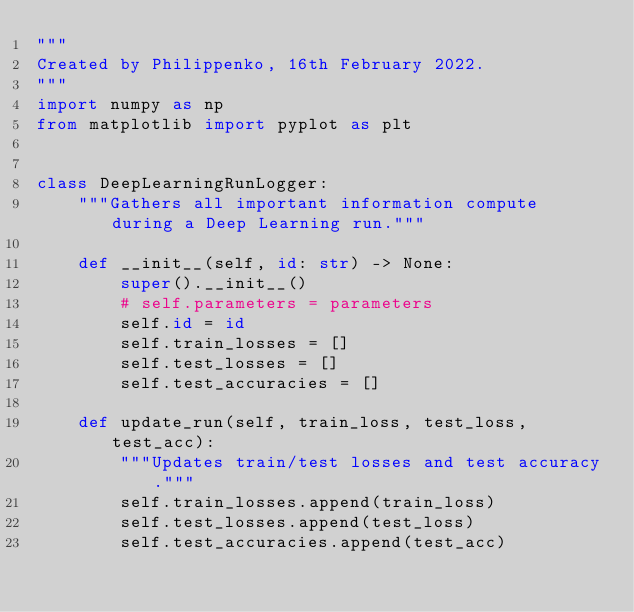Convert code to text. <code><loc_0><loc_0><loc_500><loc_500><_Python_>"""
Created by Philippenko, 16th February 2022.
"""
import numpy as np
from matplotlib import pyplot as plt


class DeepLearningRunLogger:
    """Gathers all important information compute during a Deep Learning run."""

    def __init__(self, id: str) -> None:
        super().__init__()
        # self.parameters = parameters
        self.id = id
        self.train_losses = []
        self.test_losses = []
        self.test_accuracies = []

    def update_run(self, train_loss, test_loss, test_acc):
        """Updates train/test losses and test accuracy."""
        self.train_losses.append(train_loss)
        self.test_losses.append(test_loss)
        self.test_accuracies.append(test_acc)

</code> 